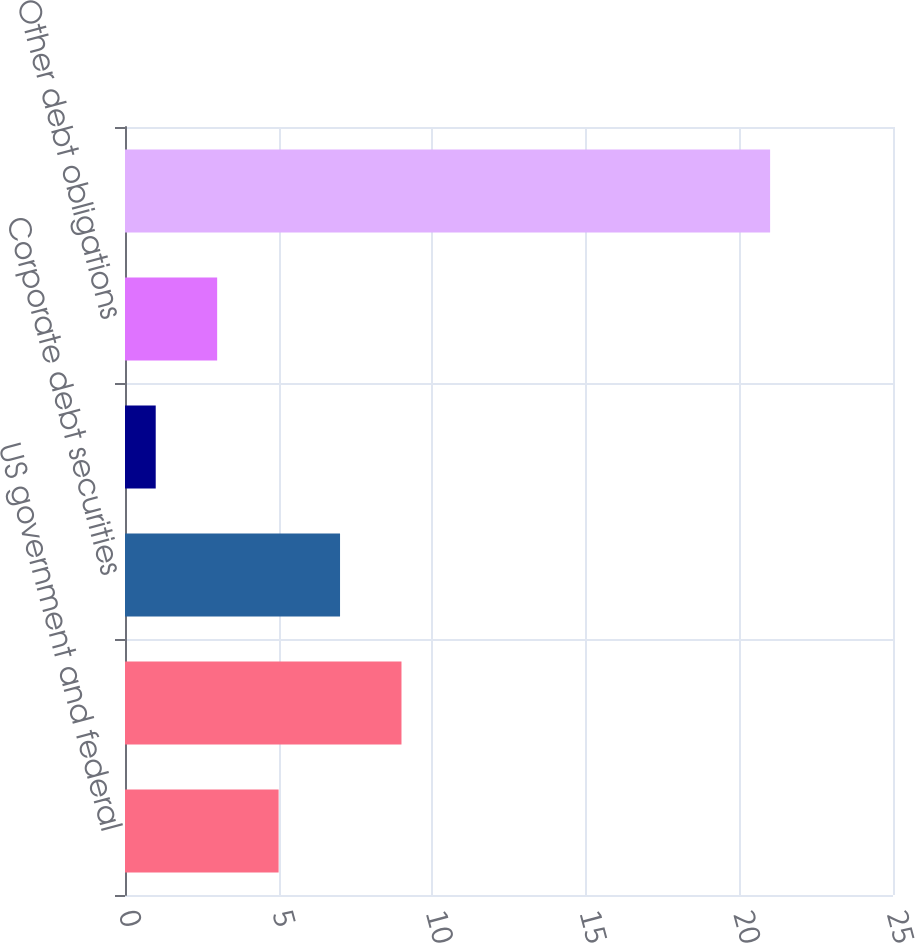<chart> <loc_0><loc_0><loc_500><loc_500><bar_chart><fcel>US government and federal<fcel>Mortgage and other<fcel>Corporate debt securities<fcel>State and municipal<fcel>Other debt obligations<fcel>Total available-for-sale<nl><fcel>5<fcel>9<fcel>7<fcel>1<fcel>3<fcel>21<nl></chart> 